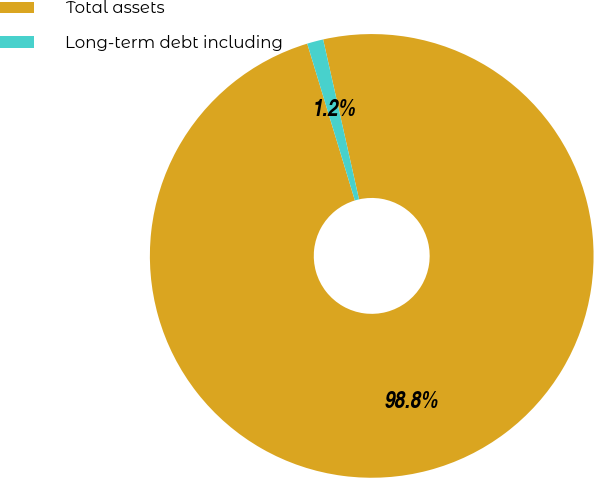<chart> <loc_0><loc_0><loc_500><loc_500><pie_chart><fcel>Total assets<fcel>Long-term debt including<nl><fcel>98.82%<fcel>1.18%<nl></chart> 